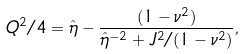Convert formula to latex. <formula><loc_0><loc_0><loc_500><loc_500>Q ^ { 2 } / 4 = \hat { \eta } - \frac { ( 1 - { \nu } ^ { 2 } ) } { { \hat { \eta } } ^ { - 2 } + J ^ { 2 } / ( 1 - { \nu } ^ { 2 } ) } ,</formula> 